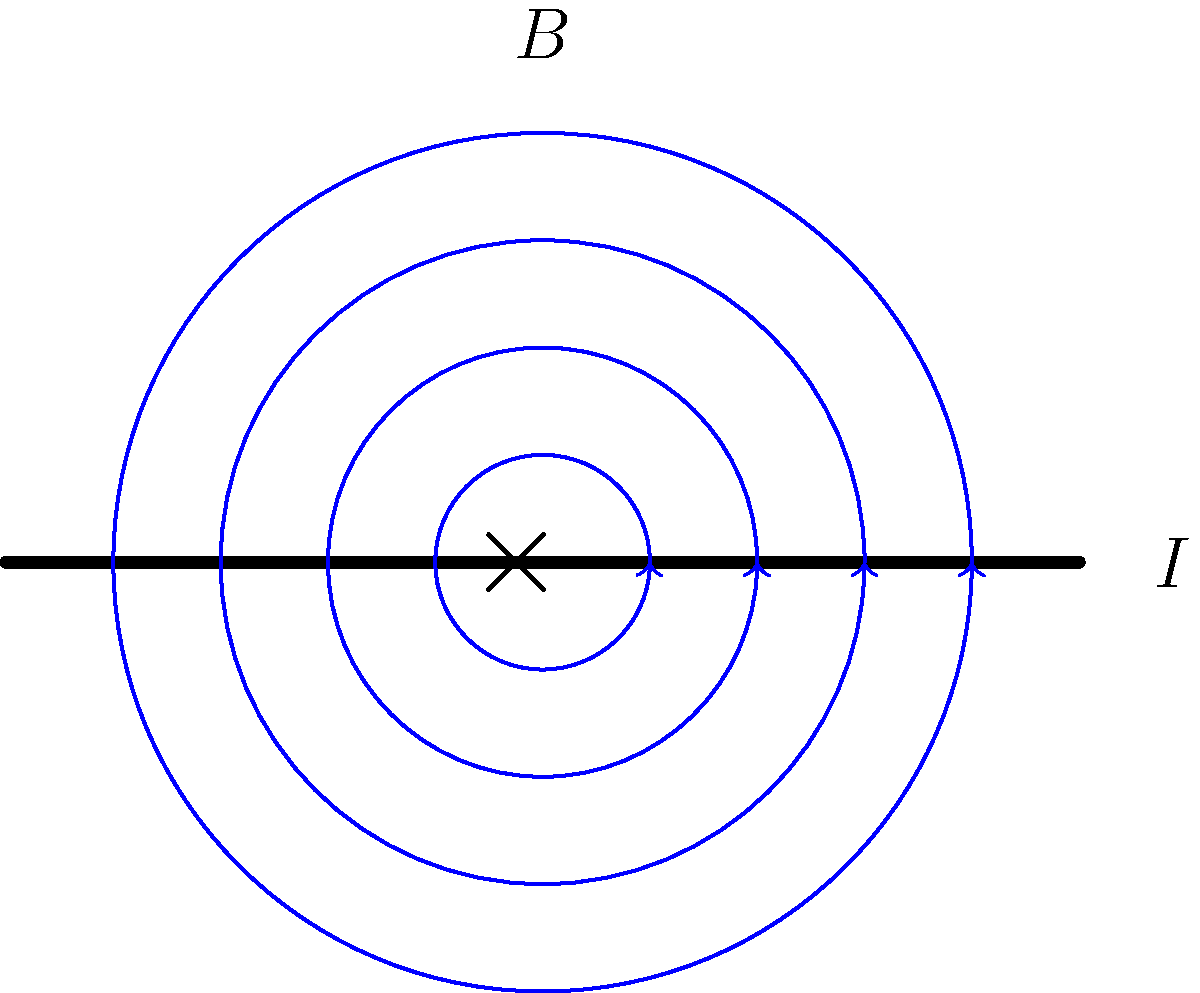In the diagram, a straight wire carries a current $I$ into the page. The magnetic field lines around the wire are represented by blue circles with arrows. Which statement most accurately describes the relationship between the current direction and the magnetic field direction, and why is this relationship significant in understanding electromagnetic phenomena? To answer this question, let's analyze the diagram and apply the relevant physical principles:

1. Current direction: The $\times$ symbol at the center of the wire indicates that the current is flowing into the page.

2. Magnetic field direction: The arrows on the blue circular lines show that the magnetic field is circulating counterclockwise around the wire.

3. Right-hand rule: To determine the relationship between current and magnetic field, we use the right-hand rule for a straight current-carrying wire:
   - Point your right thumb in the direction of the current (into the page in this case).
   - Your fingers will naturally curl in the direction of the magnetic field (counterclockwise).

4. Relationship: The magnetic field lines form concentric circles around the wire, with their direction determined by the current direction.

5. Significance: This relationship demonstrates the fundamental connection between electricity and magnetism, which is crucial in understanding electromagnetic phenomena:
   - It shows that moving charges (current) create magnetic fields.
   - The strength of the magnetic field decreases with distance from the wire, as indicated by the spacing of the field lines.
   - This principle is used in many applications, such as electromagnets and electric motors.

6. Mathematical description: The magnetic field strength $B$ at a distance $r$ from a long, straight wire carrying current $I$ is given by the equation:

   $$B = \frac{\mu_0 I}{2\pi r}$$

   where $\mu_0$ is the permeability of free space.

This relationship between current and magnetic field is a cornerstone of electromagnetism, leading to more complex concepts and applications in physics and engineering.
Answer: The current into the page produces a counterclockwise magnetic field, illustrating the right-hand rule and the fundamental link between electricity and magnetism. 